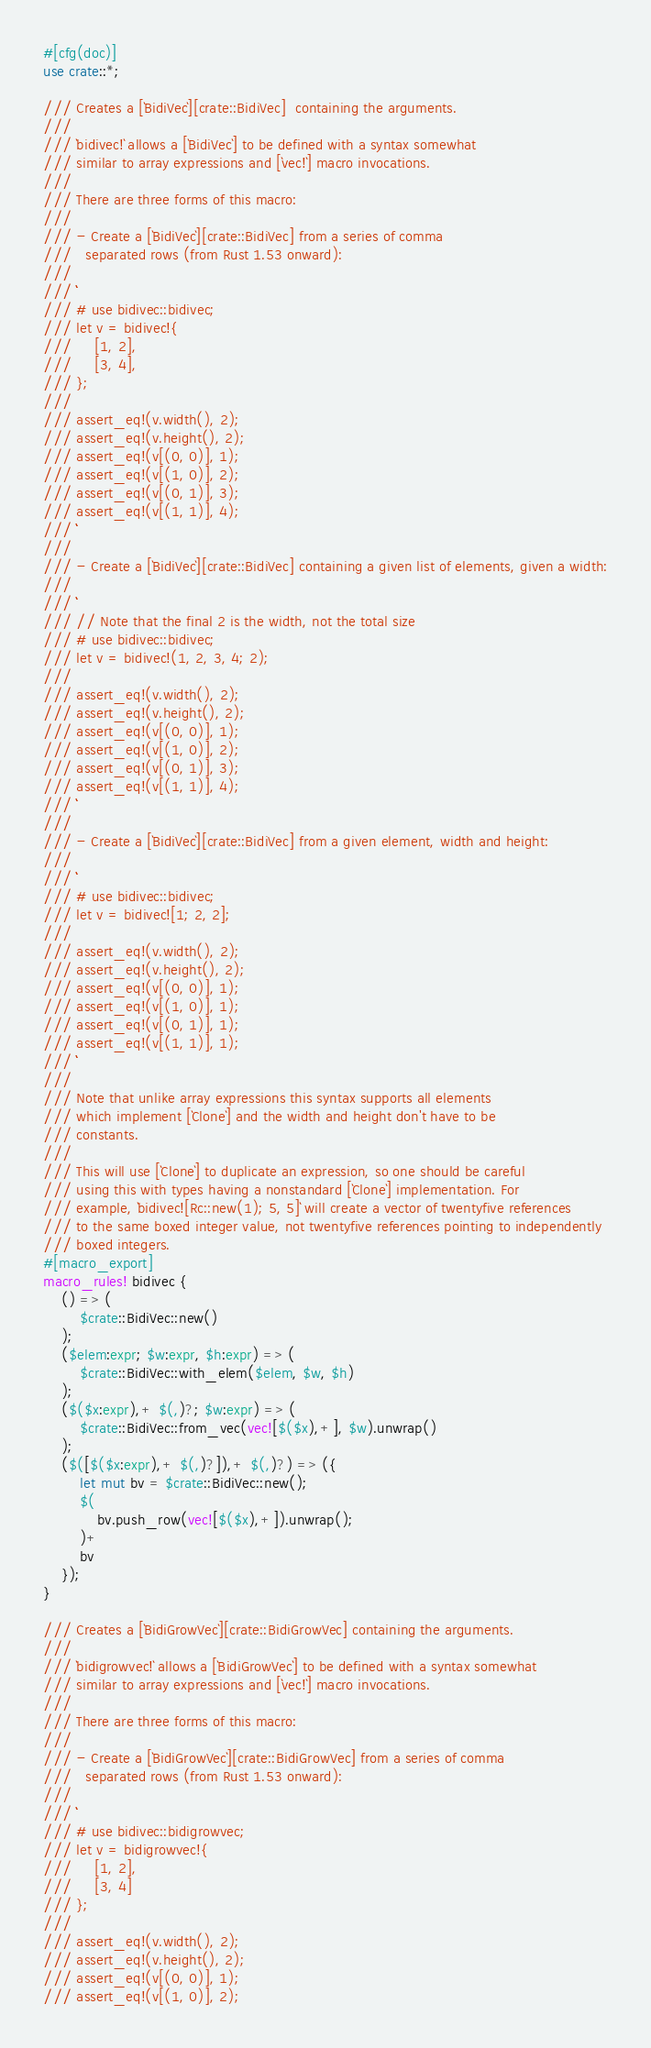Convert code to text. <code><loc_0><loc_0><loc_500><loc_500><_Rust_>#[cfg(doc)]
use crate::*;

/// Creates a [`BidiVec`][crate::BidiVec]  containing the arguments.
///
/// `bidivec!` allows a [`BidiVec`] to be defined with a syntax somewhat
/// similar to array expressions and [`vec!`] macro invocations.
///
/// There are three forms of this macro:
///
/// - Create a [`BidiVec`][crate::BidiVec] from a series of comma
///   separated rows (from Rust 1.53 onward):
///
/// ```
/// # use bidivec::bidivec;
/// let v = bidivec!{
///     [1, 2],
///     [3, 4],
/// };
///
/// assert_eq!(v.width(), 2);
/// assert_eq!(v.height(), 2);
/// assert_eq!(v[(0, 0)], 1);
/// assert_eq!(v[(1, 0)], 2);
/// assert_eq!(v[(0, 1)], 3);
/// assert_eq!(v[(1, 1)], 4);
/// ```
///
/// - Create a [`BidiVec`][crate::BidiVec] containing a given list of elements, given a width:
///
/// ```
/// // Note that the final 2 is the width, not the total size
/// # use bidivec::bidivec;
/// let v = bidivec!(1, 2, 3, 4; 2);
///
/// assert_eq!(v.width(), 2);
/// assert_eq!(v.height(), 2);
/// assert_eq!(v[(0, 0)], 1);
/// assert_eq!(v[(1, 0)], 2);
/// assert_eq!(v[(0, 1)], 3);
/// assert_eq!(v[(1, 1)], 4);
/// ```
///
/// - Create a [`BidiVec`][crate::BidiVec] from a given element, width and height:
///
/// ```
/// # use bidivec::bidivec;
/// let v = bidivec![1; 2, 2];
///
/// assert_eq!(v.width(), 2);
/// assert_eq!(v.height(), 2);
/// assert_eq!(v[(0, 0)], 1);
/// assert_eq!(v[(1, 0)], 1);
/// assert_eq!(v[(0, 1)], 1);
/// assert_eq!(v[(1, 1)], 1);
/// ```
///
/// Note that unlike array expressions this syntax supports all elements
/// which implement [`Clone`] and the width and height don't have to be
/// constants.
///
/// This will use [`Clone`] to duplicate an expression, so one should be careful
/// using this with types having a nonstandard [`Clone`] implementation. For
/// example, `bidivec![Rc::new(1); 5, 5]` will create a vector of twentyfive references
/// to the same boxed integer value, not twentyfive references pointing to independently
/// boxed integers.
#[macro_export]
macro_rules! bidivec {
    () => (
        $crate::BidiVec::new()
    );
    ($elem:expr; $w:expr, $h:expr) => (
        $crate::BidiVec::with_elem($elem, $w, $h)
    );
    ($($x:expr),+ $(,)?; $w:expr) => (
        $crate::BidiVec::from_vec(vec![$($x),+], $w).unwrap()
    );
    ($([$($x:expr),+ $(,)?]),+ $(,)?) => ({
        let mut bv = $crate::BidiVec::new();
        $(
            bv.push_row(vec![$($x),+]).unwrap();
        )+
        bv
    });
}

/// Creates a [`BidiGrowVec`][crate::BidiGrowVec] containing the arguments.
///
/// `bidigrowvec!` allows a [`BidiGrowVec`] to be defined with a syntax somewhat
/// similar to array expressions and [`vec!`] macro invocations.
///
/// There are three forms of this macro:
///
/// - Create a [`BidiGrowVec`][crate::BidiGrowVec] from a series of comma
///   separated rows (from Rust 1.53 onward):
///
/// ```
/// # use bidivec::bidigrowvec;
/// let v = bidigrowvec!{
///     [1, 2],
///     [3, 4]
/// };
///
/// assert_eq!(v.width(), 2);
/// assert_eq!(v.height(), 2);
/// assert_eq!(v[(0, 0)], 1);
/// assert_eq!(v[(1, 0)], 2);</code> 